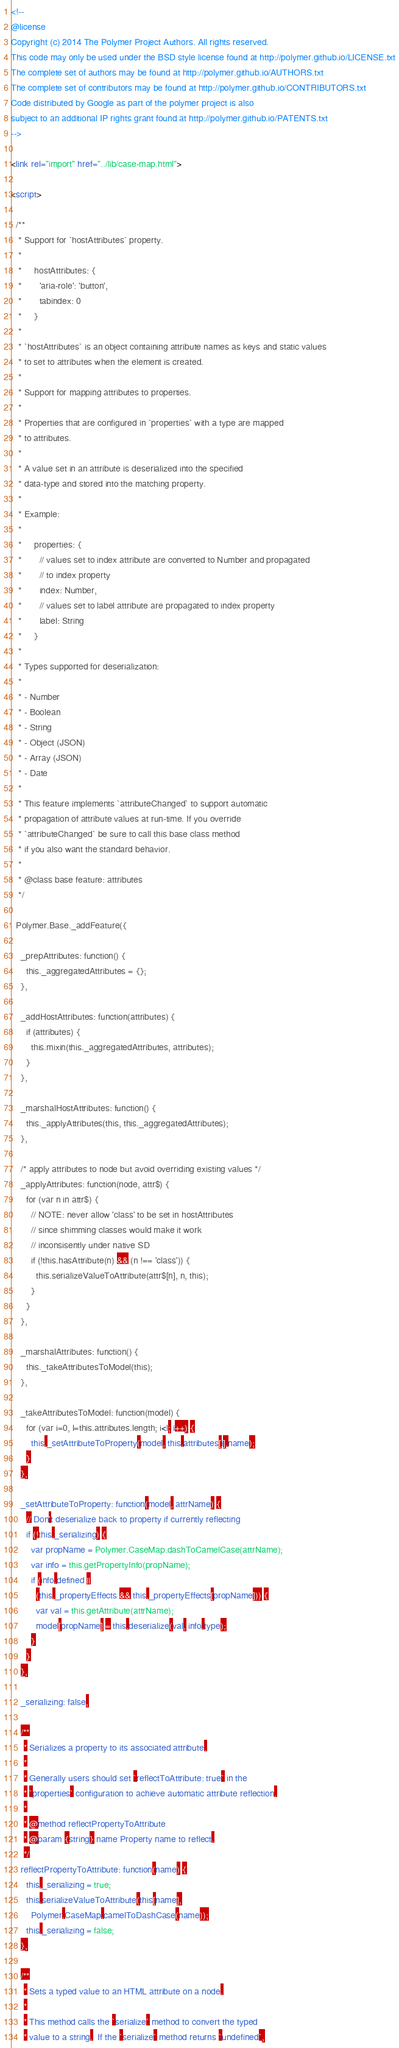Convert code to text. <code><loc_0><loc_0><loc_500><loc_500><_HTML_><!--
@license
Copyright (c) 2014 The Polymer Project Authors. All rights reserved.
This code may only be used under the BSD style license found at http://polymer.github.io/LICENSE.txt
The complete set of authors may be found at http://polymer.github.io/AUTHORS.txt
The complete set of contributors may be found at http://polymer.github.io/CONTRIBUTORS.txt
Code distributed by Google as part of the polymer project is also
subject to an additional IP rights grant found at http://polymer.github.io/PATENTS.txt
-->

<link rel="import" href="../lib/case-map.html">

<script>

  /**
   * Support for `hostAttributes` property.
   *
   *     hostAttributes: {
   *       'aria-role': 'button',
   *       tabindex: 0
   *     }
   *
   * `hostAttributes` is an object containing attribute names as keys and static values
   * to set to attributes when the element is created.
   *
   * Support for mapping attributes to properties.
   *
   * Properties that are configured in `properties` with a type are mapped
   * to attributes.
   *
   * A value set in an attribute is deserialized into the specified
   * data-type and stored into the matching property.
   *
   * Example:
   *
   *     properties: {
   *       // values set to index attribute are converted to Number and propagated
   *       // to index property
   *       index: Number,
   *       // values set to label attribute are propagated to index property
   *       label: String
   *     }
   *
   * Types supported for deserialization:
   *
   * - Number
   * - Boolean
   * - String
   * - Object (JSON)
   * - Array (JSON)
   * - Date
   *
   * This feature implements `attributeChanged` to support automatic
   * propagation of attribute values at run-time. If you override
   * `attributeChanged` be sure to call this base class method
   * if you also want the standard behavior.
   *
   * @class base feature: attributes
   */

  Polymer.Base._addFeature({

    _prepAttributes: function() {
      this._aggregatedAttributes = {};
    },

    _addHostAttributes: function(attributes) {
      if (attributes) {
        this.mixin(this._aggregatedAttributes, attributes);
      }
    },

    _marshalHostAttributes: function() {
      this._applyAttributes(this, this._aggregatedAttributes);
    },

    /* apply attributes to node but avoid overriding existing values */
    _applyAttributes: function(node, attr$) {
      for (var n in attr$) {
        // NOTE: never allow 'class' to be set in hostAttributes
        // since shimming classes would make it work
        // inconsisently under native SD
        if (!this.hasAttribute(n) && (n !== 'class')) {
          this.serializeValueToAttribute(attr$[n], n, this);
        }
      }
    },

    _marshalAttributes: function() {
      this._takeAttributesToModel(this);
    },

    _takeAttributesToModel: function(model) {
      for (var i=0, l=this.attributes.length; i<l; i++) {
        this._setAttributeToProperty(model, this.attributes[i].name);
      }
    },

    _setAttributeToProperty: function(model, attrName) {
      // Don't deserialize back to property if currently reflecting
      if (!this._serializing) {
        var propName = Polymer.CaseMap.dashToCamelCase(attrName);
        var info = this.getPropertyInfo(propName);
        if (info.defined ||
          (this._propertyEffects && this._propertyEffects[propName])) {
          var val = this.getAttribute(attrName);
          model[propName] = this.deserialize(val, info.type);
        }
      }
    },

    _serializing: false,

    /**
     * Serializes a property to its associated attribute.
     *
     * Generally users should set `reflectToAttribute: true` in the
     * `properties` configuration to achieve automatic attribute reflection.
     *
     * @method reflectPropertyToAttribute
     * @param {string} name Property name to reflect.
     */
    reflectPropertyToAttribute: function(name) {
      this._serializing = true;
      this.serializeValueToAttribute(this[name],
        Polymer.CaseMap.camelToDashCase(name));
      this._serializing = false;
    },

    /**
     * Sets a typed value to an HTML attribute on a node.
     *
     * This method calls the `serialize` method to convert the typed
     * value to a string.  If the `serialize` method returns `undefined`,</code> 